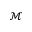Convert formula to latex. <formula><loc_0><loc_0><loc_500><loc_500>\mathcal { M }</formula> 